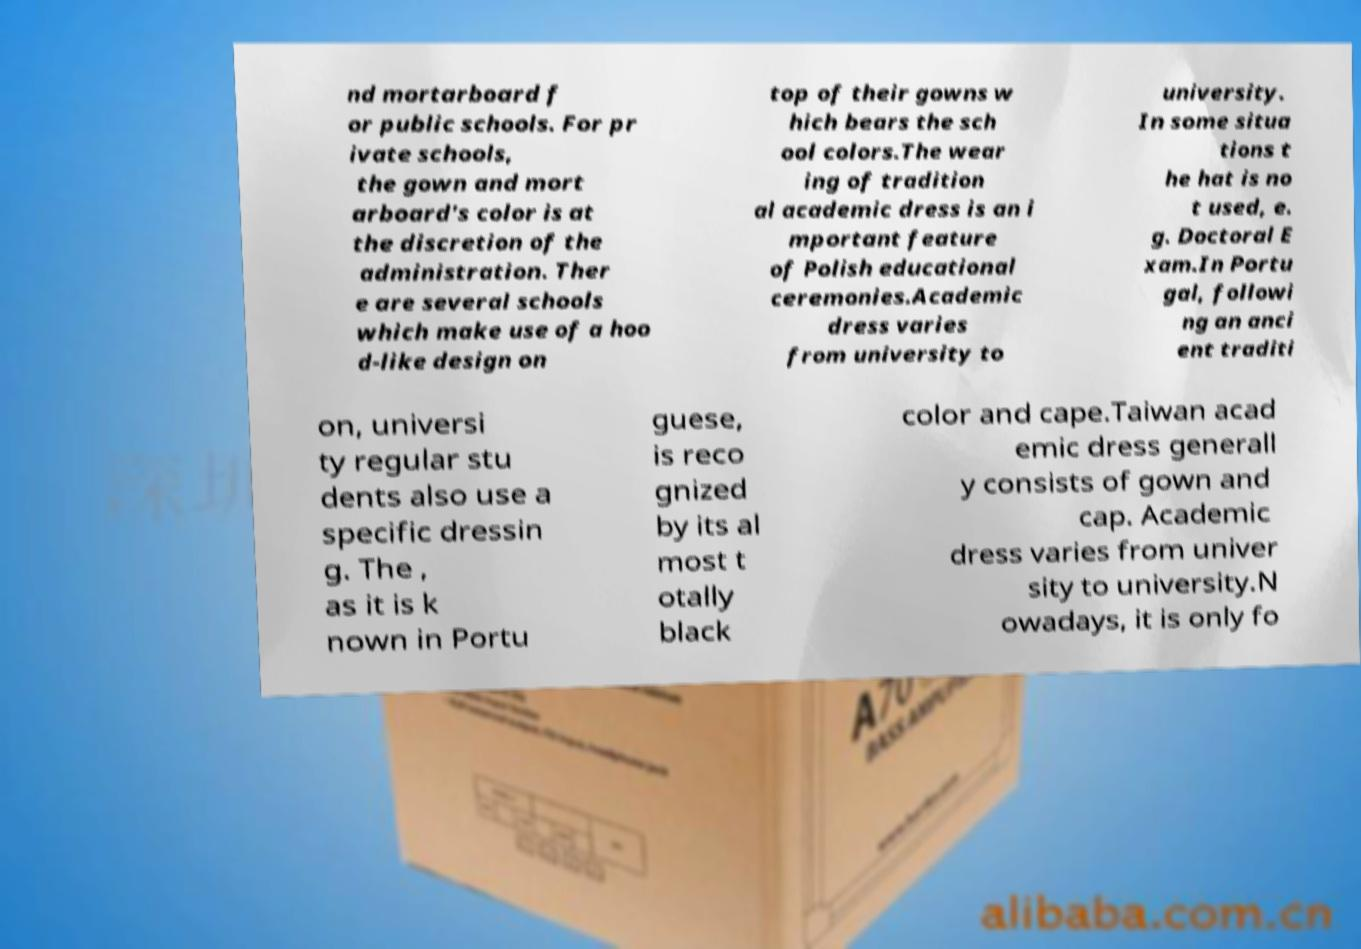For documentation purposes, I need the text within this image transcribed. Could you provide that? nd mortarboard f or public schools. For pr ivate schools, the gown and mort arboard's color is at the discretion of the administration. Ther e are several schools which make use of a hoo d-like design on top of their gowns w hich bears the sch ool colors.The wear ing of tradition al academic dress is an i mportant feature of Polish educational ceremonies.Academic dress varies from university to university. In some situa tions t he hat is no t used, e. g. Doctoral E xam.In Portu gal, followi ng an anci ent traditi on, universi ty regular stu dents also use a specific dressin g. The , as it is k nown in Portu guese, is reco gnized by its al most t otally black color and cape.Taiwan acad emic dress generall y consists of gown and cap. Academic dress varies from univer sity to university.N owadays, it is only fo 